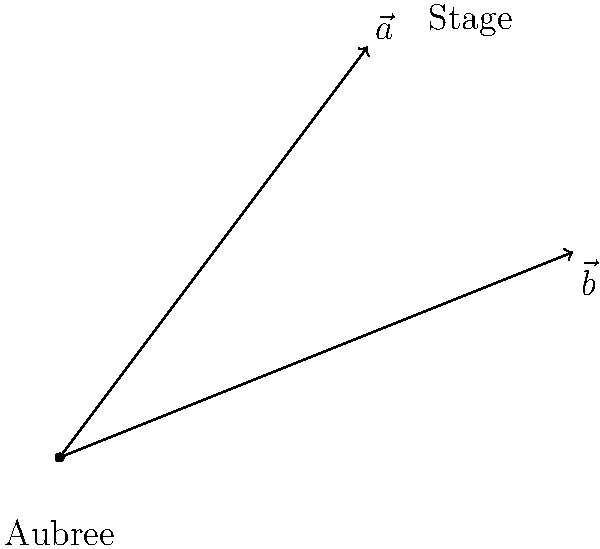At Aubree Riley's concert, two stage lights are represented by vectors $\vec{a} = 3\hat{i} + 4\hat{j}$ and $\vec{b} = 5\hat{i} + 2\hat{j}$. What is the magnitude of the projection of $\vec{a}$ onto $\vec{b}$, rounded to two decimal places? To find the projection of $\vec{a}$ onto $\vec{b}$, we'll follow these steps:

1) The formula for the projection of $\vec{a}$ onto $\vec{b}$ is:

   $\text{proj}_{\vec{b}}\vec{a} = \frac{\vec{a} \cdot \vec{b}}{\|\vec{b}\|^2} \vec{b}$

2) First, let's calculate the dot product $\vec{a} \cdot \vec{b}$:
   $\vec{a} \cdot \vec{b} = (3)(5) + (4)(2) = 15 + 8 = 23$

3) Next, we need to calculate $\|\vec{b}\|^2$:
   $\|\vec{b}\|^2 = 5^2 + 2^2 = 25 + 4 = 29$

4) Now we can find the scalar projection:
   $\frac{\vec{a} \cdot \vec{b}}{\|\vec{b}\|^2} = \frac{23}{29}$

5) The vector projection would be $\frac{23}{29}\vec{b}$, but we only need the magnitude.

6) The magnitude of the projection is:
   $\|\text{proj}_{\vec{b}}\vec{a}\| = \frac{23}{29}\|\vec{b}\| = \frac{23}{29}\sqrt{29} = 23/\sqrt{29} \approx 4.27$

7) Rounding to two decimal places: 4.27
Answer: 4.27 